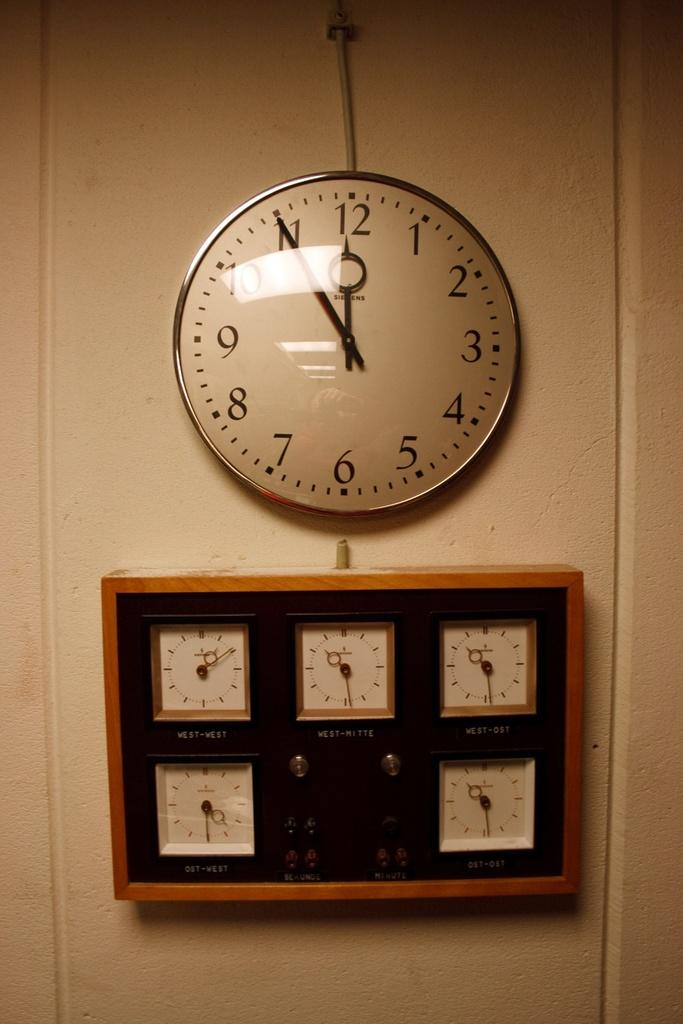<image>
Share a concise interpretation of the image provided. A grid of clock faces, including West-West and West-Mitte, hangs below a round clock. 